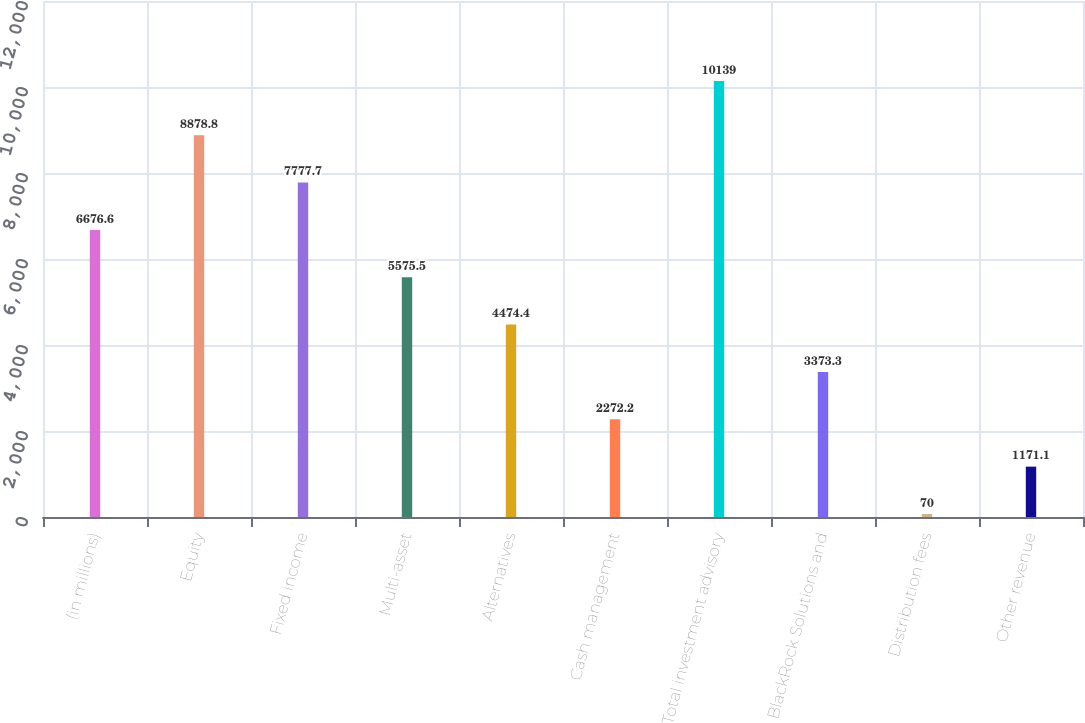<chart> <loc_0><loc_0><loc_500><loc_500><bar_chart><fcel>(in millions)<fcel>Equity<fcel>Fixed income<fcel>Multi-asset<fcel>Alternatives<fcel>Cash management<fcel>Total investment advisory<fcel>BlackRock Solutions and<fcel>Distribution fees<fcel>Other revenue<nl><fcel>6676.6<fcel>8878.8<fcel>7777.7<fcel>5575.5<fcel>4474.4<fcel>2272.2<fcel>10139<fcel>3373.3<fcel>70<fcel>1171.1<nl></chart> 